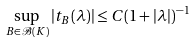<formula> <loc_0><loc_0><loc_500><loc_500>\sup _ { B \in \mathcal { B } ( K ) } | t _ { B } ( \lambda ) | \leq C ( 1 + | \lambda | ) ^ { - 1 }</formula> 